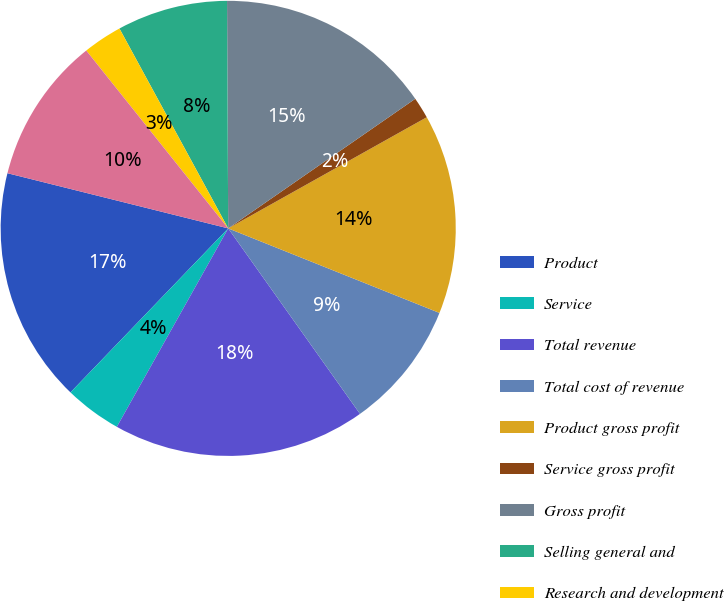Convert chart. <chart><loc_0><loc_0><loc_500><loc_500><pie_chart><fcel>Product<fcel>Service<fcel>Total revenue<fcel>Total cost of revenue<fcel>Product gross profit<fcel>Service gross profit<fcel>Gross profit<fcel>Selling general and<fcel>Research and development<fcel>Total operating expenses<nl><fcel>16.71%<fcel>4.05%<fcel>17.97%<fcel>9.11%<fcel>14.18%<fcel>1.52%<fcel>15.44%<fcel>7.85%<fcel>2.79%<fcel>10.38%<nl></chart> 